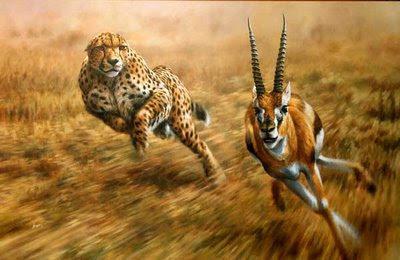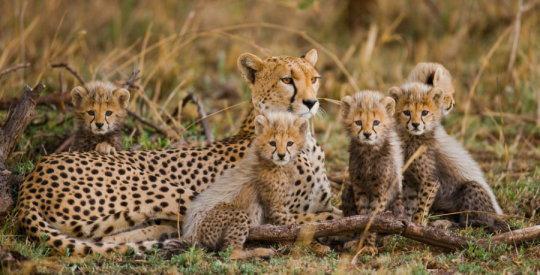The first image is the image on the left, the second image is the image on the right. Considering the images on both sides, is "There are exactly two animals in the image on the left." valid? Answer yes or no. Yes. The first image is the image on the left, the second image is the image on the right. Given the left and right images, does the statement "One image includes more than one spotted cat on the ground." hold true? Answer yes or no. Yes. 